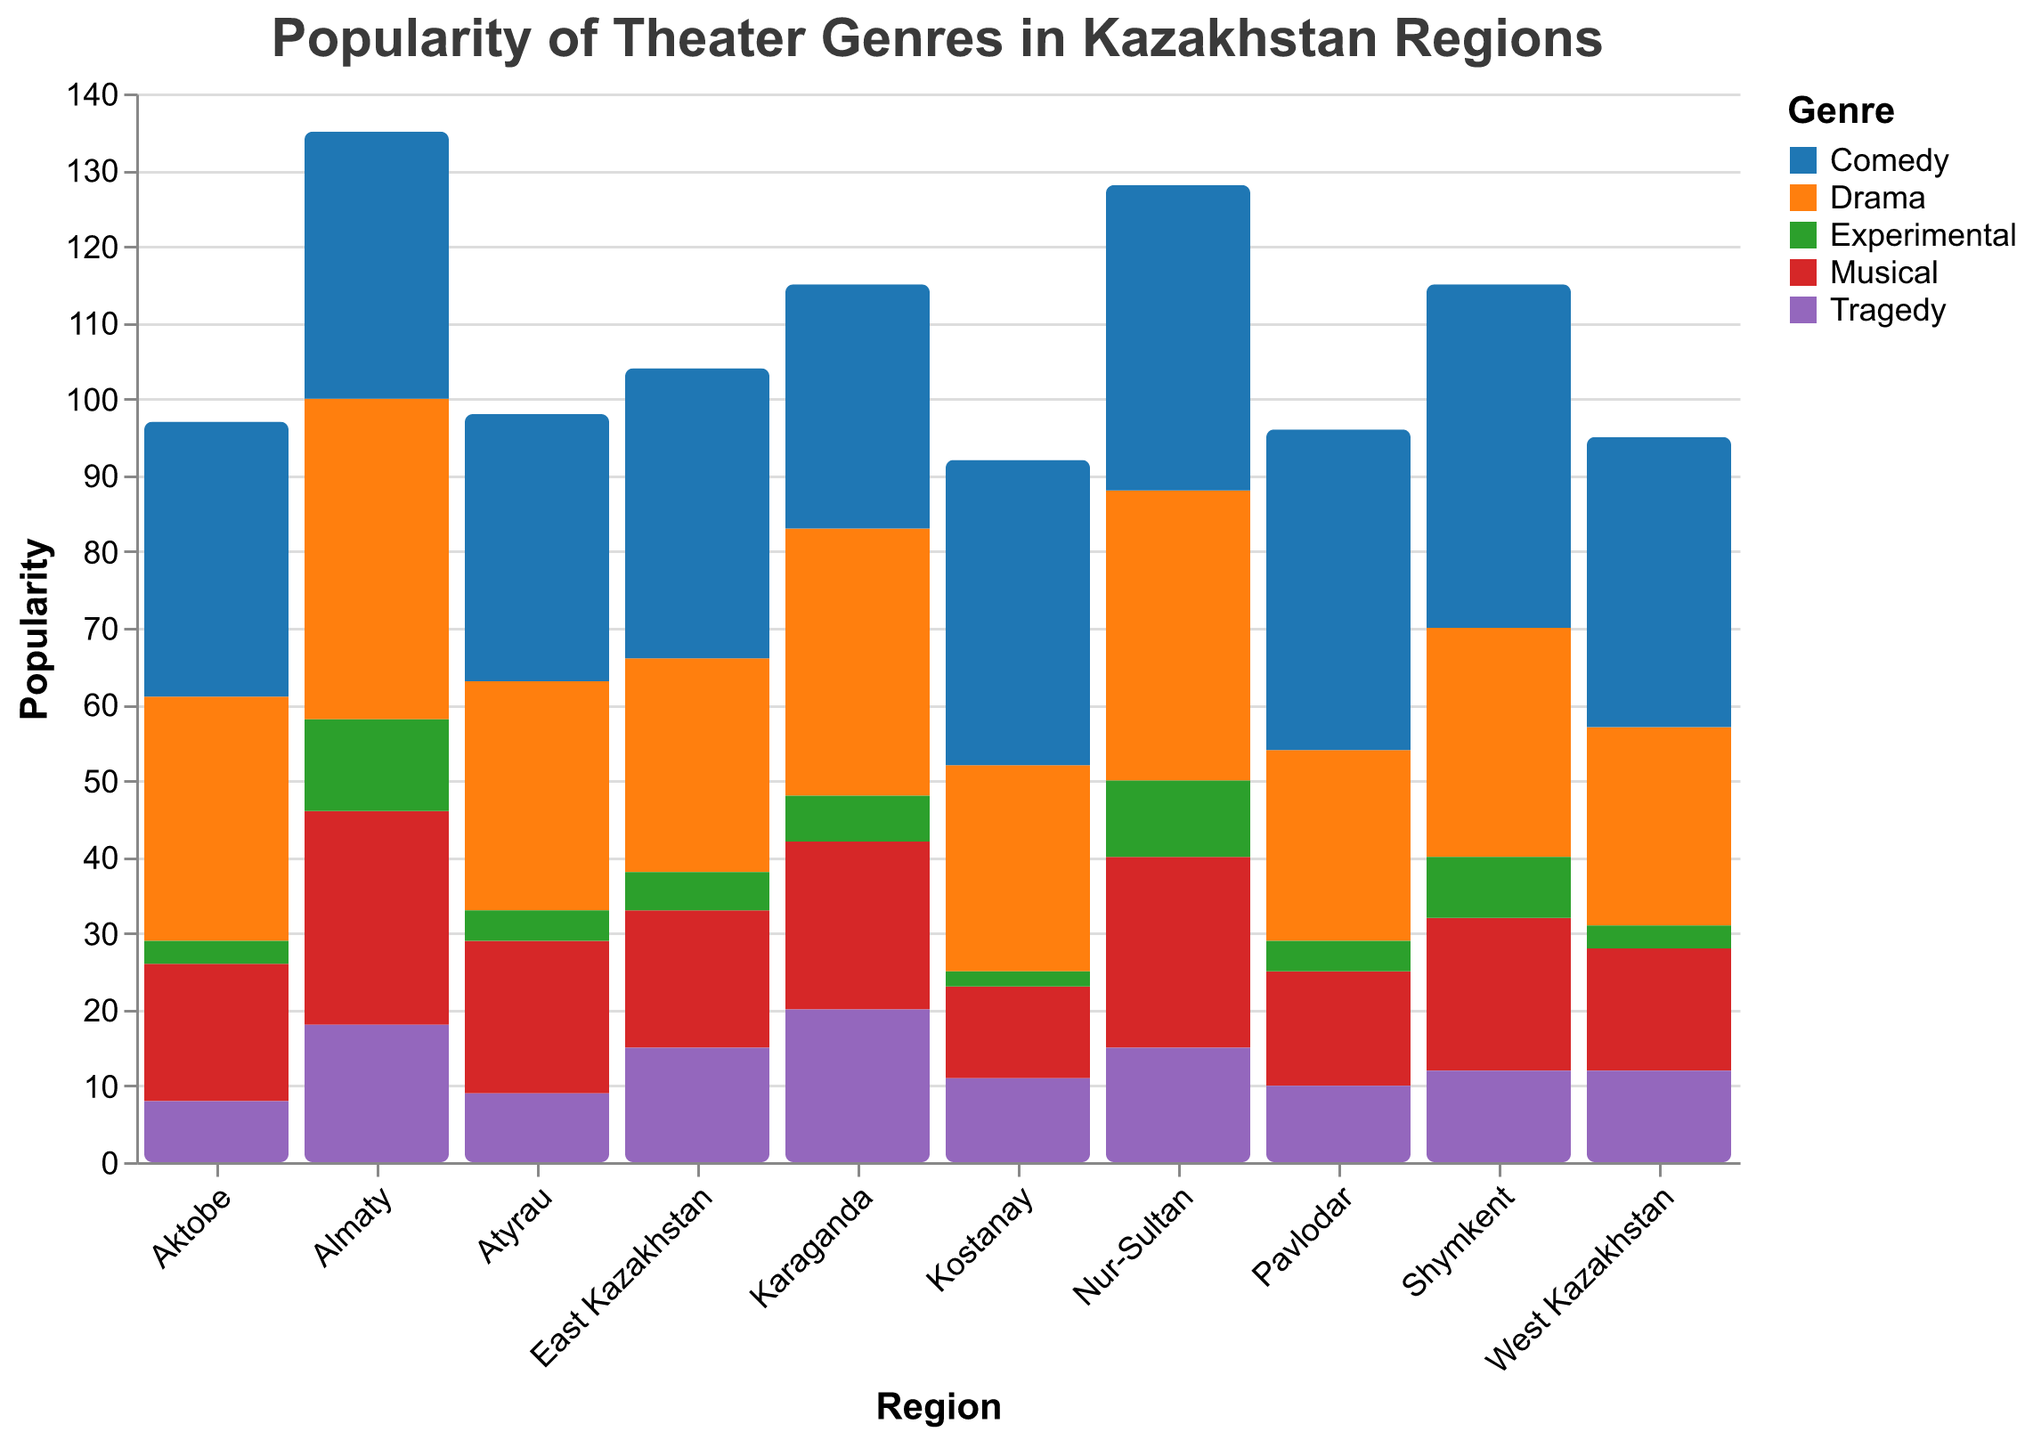What is the most popular theater genre in Almaty? Look at the bars representing Almaty. The Drama genre has the highest value with 42.
Answer: Drama Which region has the highest popularity for comedy? By observing the Comedy bars for all regions, Shymkent has the highest popularity with a value of 45.
Answer: Shymkent What are the least popular genres in Pavlodar? Check the values for each genre in the Pavlodar region. The Experimental genre has the lowest popularity with a value of 4.
Answer: Experimental Is the Musical genre more popular in Almaty or Nur-Sultan? Compare the heights of the Musical bars for both Almaty and Nur-Sultan. Almaty has 28 and Nur-Sultan has 25, so it's more popular in Almaty.
Answer: Almaty What is the average popularity of the Tragedy genre across all regions? Sum the values for the Tragedy genre in all regions (18+15+12+20+15+10+8+11+9+12 = 130) and divide by the number of regions (10). 130/10 = 13.
Answer: 13 Which region has the lowest popularity for Experimental theater? Look at the Experimental bars for all regions. Kostanay has the lowest popularity with a value of 2.
Answer: Kostanay Compare the popularity of Drama and Comedy in Karaganda. Which one is more popular? Check the bars for Drama and Comedy in Karaganda. Drama has a value of 35 and Comedy has 32. Drama is more popular.
Answer: Drama How many regions have higher popularity for Comedy than for Drama? Compare the Comedy and Drama values for each region. Regions are: Nur-Sultan (40 > 38), Shymkent (45 > 30), East Kazakhstan (38 > 28), Pavlodar (42 > 25), Kostanay (40 > 27), West Kazakhstan (38 > 26). Total 6 regions.
Answer: 6 What is the total popularity of Experimental theater across all regions? Sum the values for the Experimental genre across all regions (12+10+8+6+5+4+3+2+4+3 = 57).
Answer: 57 Which region shows a near-equal preference for Drama and Comedy? Compare the values of Drama and Comedy in each region and find those with close values. Almaty (42, 35) and Aktobe (32, 36) are good candidates.
Answer: Aktobe 